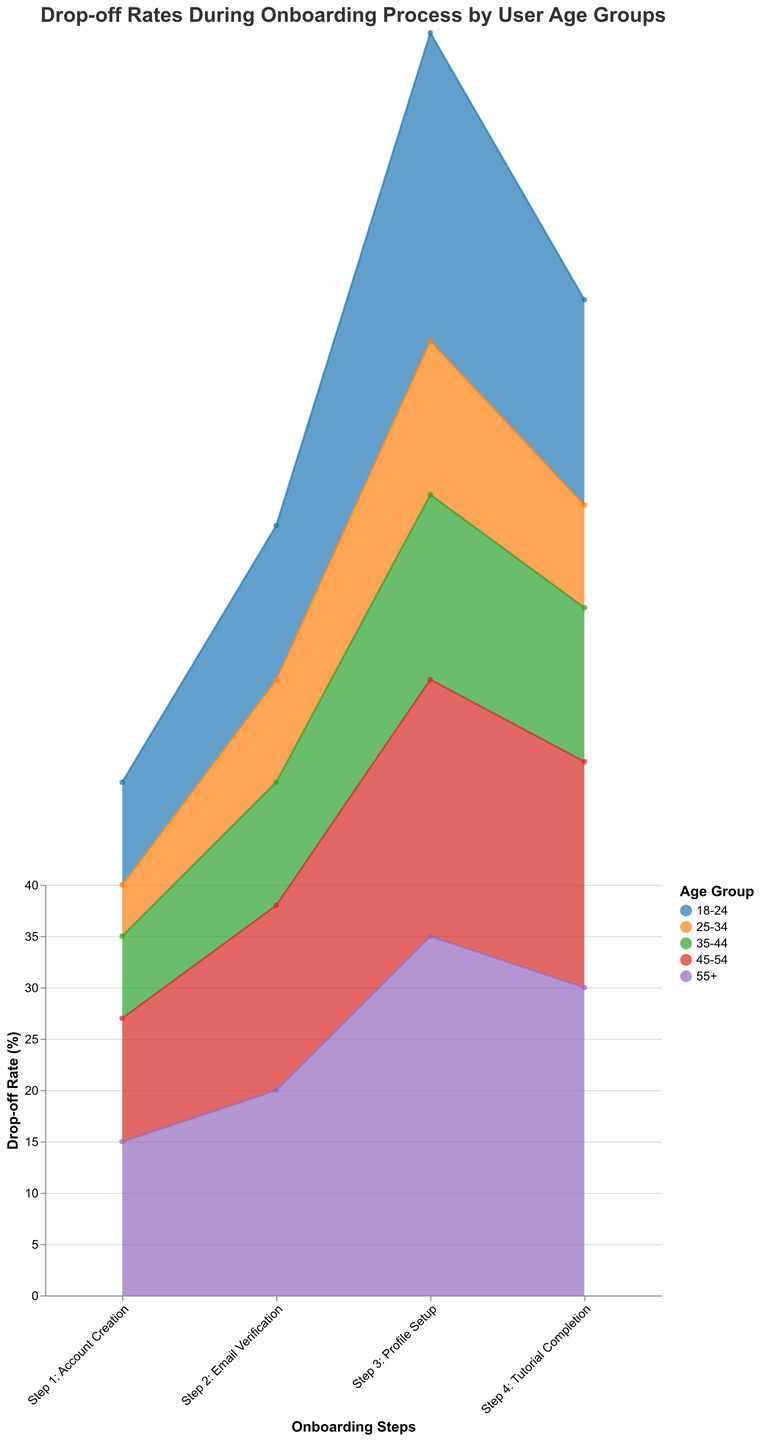What is the drop-off rate for the age group 18-24 at Step 1: Account Creation? To find the drop-off rate for the age group 18-24 at Step 1, refer to the corresponding point on the step area chart. The drop-off rate is clearly labeled as 10%.
Answer: 10% Which age group has the highest drop-off rate at Step 3: Profile Setup? At Step 3: Profile Setup, compare the drop-off rates of all age groups. The age group 55+ has the highest drop-off rate of 35%.
Answer: 55+ What is the difference in drop-off rates between Step 3 and Step 4 for the age group 45-54? Find the drop-off rates at Step 3 and Step 4 for age group 45-54: 25% and 22%, respectively. The difference is 25% - 22% = 3%.
Answer: 3% Which step has the highest average drop-off rate across all age groups? Calculate the average drop-off rate for each step by summing the drop-off rates across all age groups and dividing by the number of age groups. Step 3 has the highest average drop-off rate.
Answer: Step 3: Profile Setup Among all age groups, which group has the lowest drop-off rate at any step, and what is the value? Identify the lowest drop-off rate from all the steps for each age group. The age group 25-34 at Step 1: Account Creation has the lowest drop-off rate of 5%.
Answer: 25-34, 5% At which step do most age groups experience their highest drop-off rate? Review each age group's drop-off rates across all steps and identify the step with the most occurrences of being the highest drop-off rate. Most age groups experience their highest drop-off rate at Step 3: Profile Setup.
Answer: Step 3: Profile Setup What is the total drop-off rate for the age group 35-44 across all steps? Sum the drop-off rates for the age group 35-44 across all steps: 8% + 12% + 18% + 15% = 53%.
Answer: 53% Does any age group have an increasing trend in drop-off rates from Step 1 to Step 4? Check the drop-off rates for each age group from Step 1 to Step 4 and see if the rates increase consistently. No age group shows an increasing trend from Step 1 to Step 4.
Answer: No What is the average drop-off rate at Step 2: Email Verification for all age groups? Sum the drop-off rates at Step 2: Email Verification across all age groups and divide by the number of age groups: (15% + 10% + 12% + 18% + 20%) / 5 = 15%.
Answer: 15% Which age group shows the smallest variation in drop-off rates across all steps? Calculate the drop-off rate range (max drop-off - min drop-off) for each age group and identify the smallest one. Age group 25-34 has the smallest variation of 10% (15% - 5%).
Answer: 25-34, 10% 